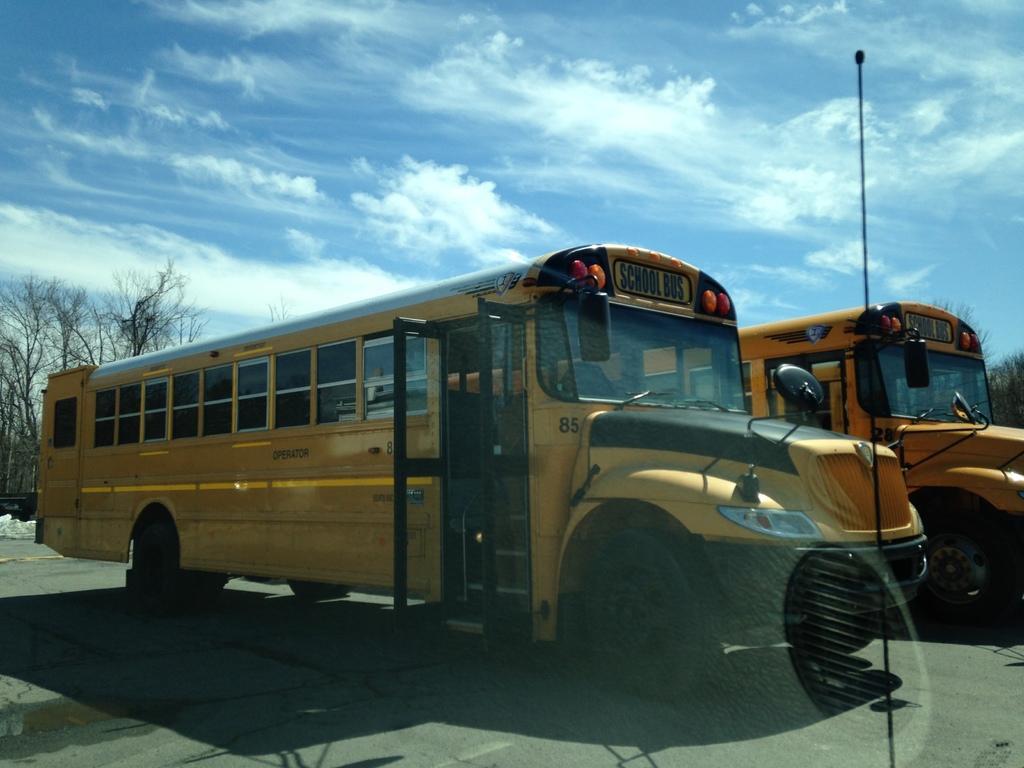Please provide a concise description of this image. In this image there are buses on a road, in the background there are trees and blue sky. 